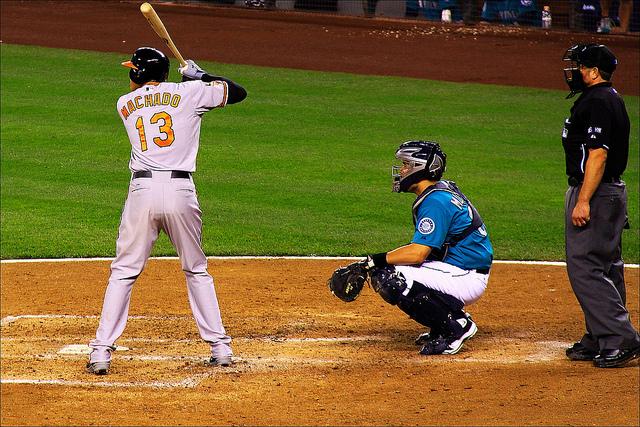Is the catcher's shirt blue?
Quick response, please. Yes. What is the number on the batters' shirt?
Quick response, please. 13. What is the color of the glove?
Give a very brief answer. Black. How many people have on masks?
Short answer required. 2. What is the name on the batter's Jersey?
Write a very short answer. Machado. 